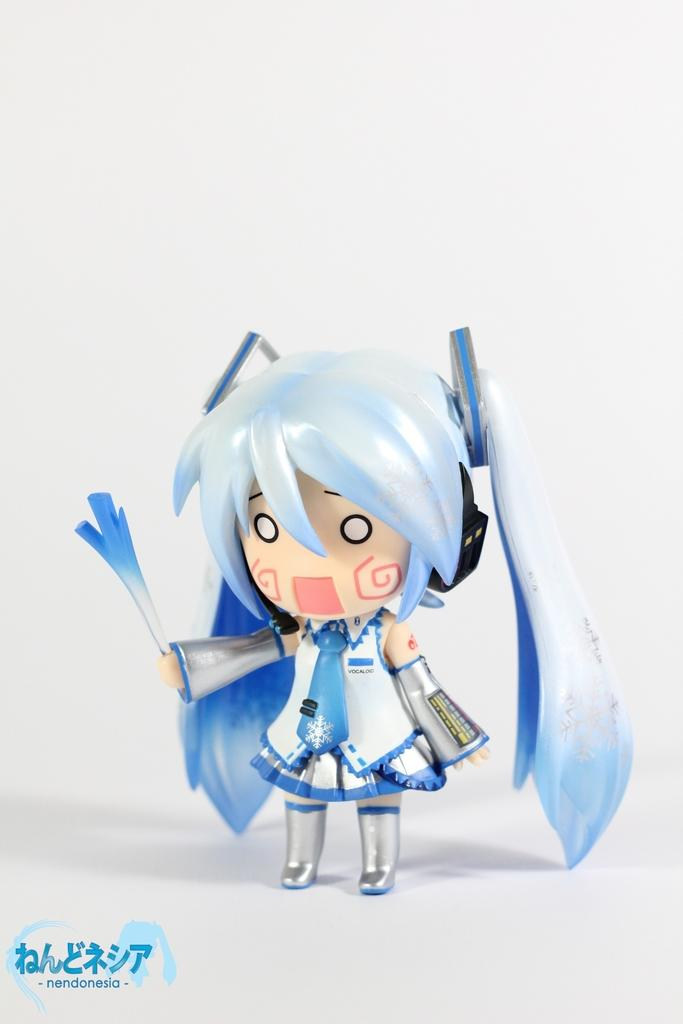What is the main subject of the image? There is a toy of a girl in the image. Is there any text present in the image? Yes, there is text in the bottom left corner of the image. What color is the background of the image? The background of the image is white. What type of sand can be seen in the image? There is no sand present in the image. What shape is the toy of the girl in the image? The provided facts do not mention the shape of the toy of the girl, so we cannot determine its shape from the information given. 